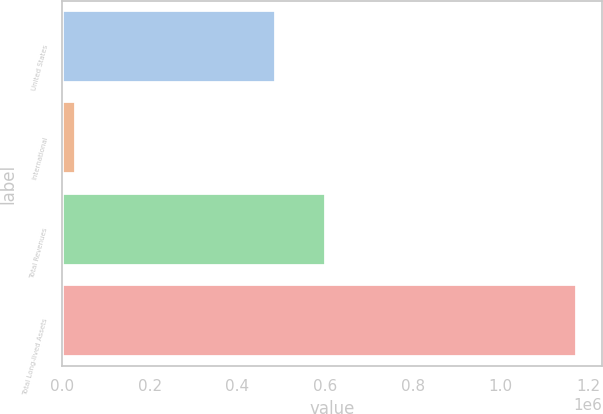<chart> <loc_0><loc_0><loc_500><loc_500><bar_chart><fcel>United States<fcel>International<fcel>Total Revenues<fcel>Total Long-lived Assets<nl><fcel>487931<fcel>31618<fcel>602124<fcel>1.17355e+06<nl></chart> 